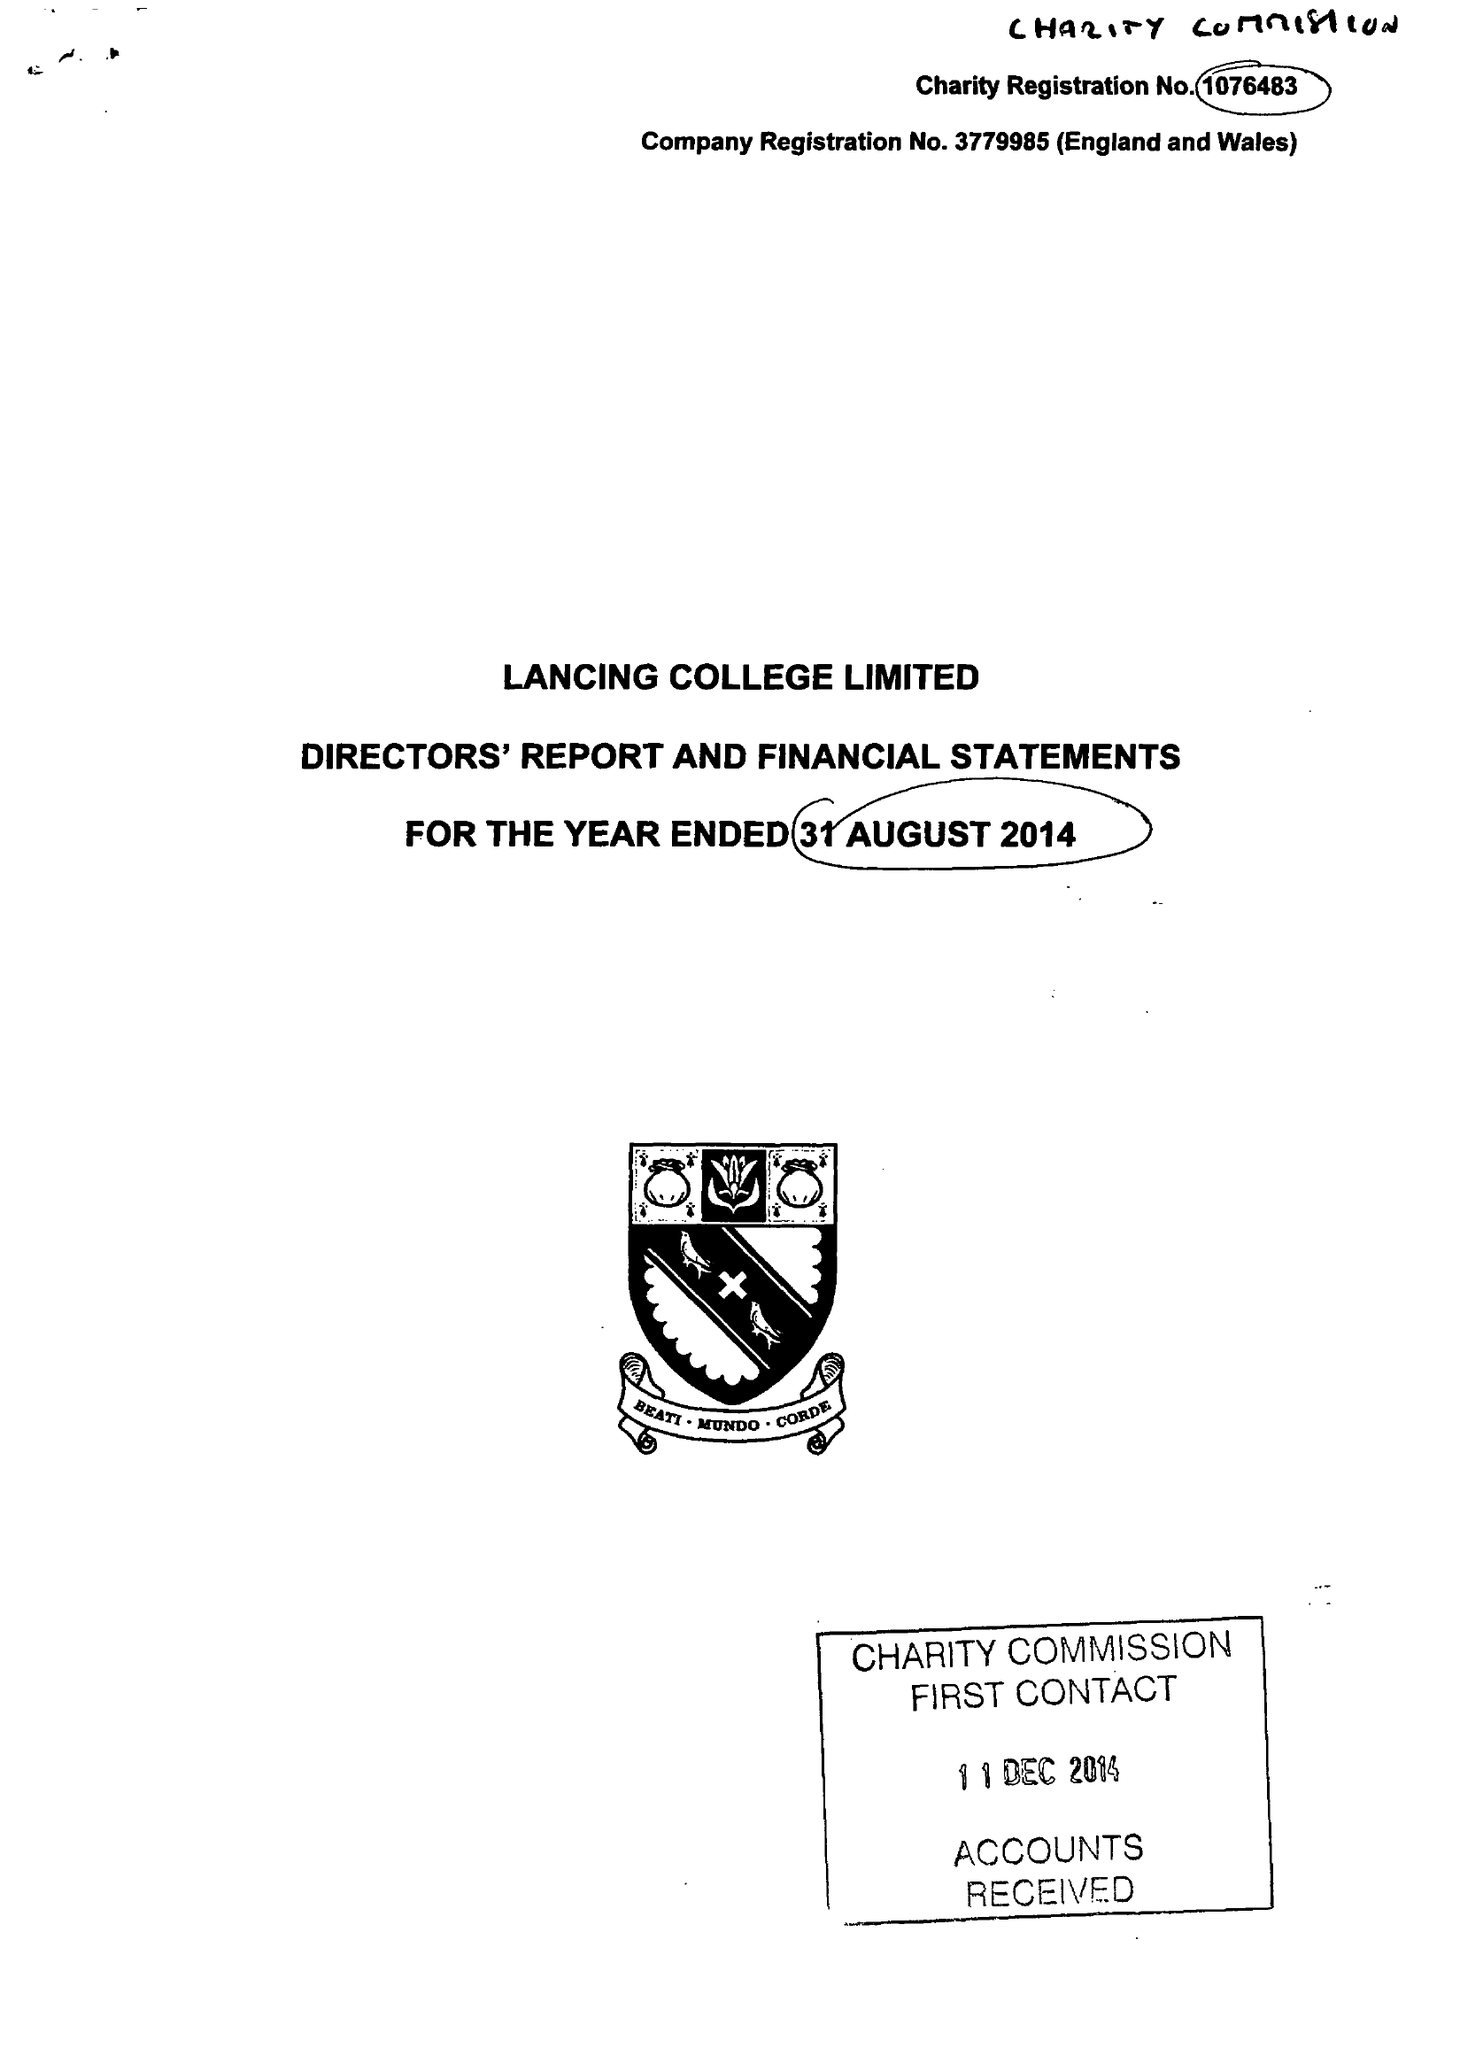What is the value for the address__street_line?
Answer the question using a single word or phrase. None 